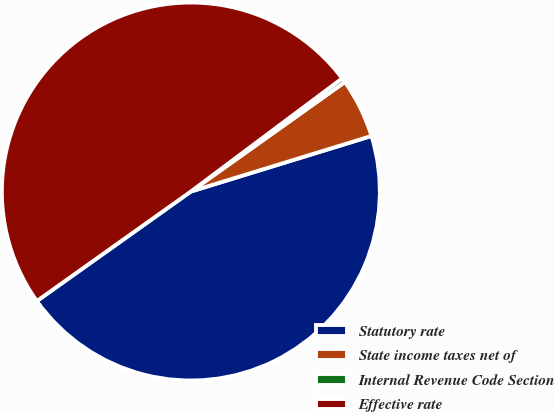<chart> <loc_0><loc_0><loc_500><loc_500><pie_chart><fcel>Statutory rate<fcel>State income taxes net of<fcel>Internal Revenue Code Section<fcel>Effective rate<nl><fcel>44.91%<fcel>5.09%<fcel>0.38%<fcel>49.62%<nl></chart> 